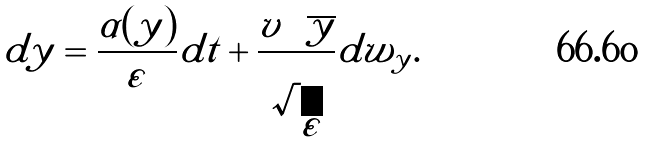<formula> <loc_0><loc_0><loc_500><loc_500>d y = \frac { \alpha ( y ) } { \varepsilon } d t + \frac { v \sqrt { y } } { \sqrt { \varepsilon } } d w _ { y } .</formula> 